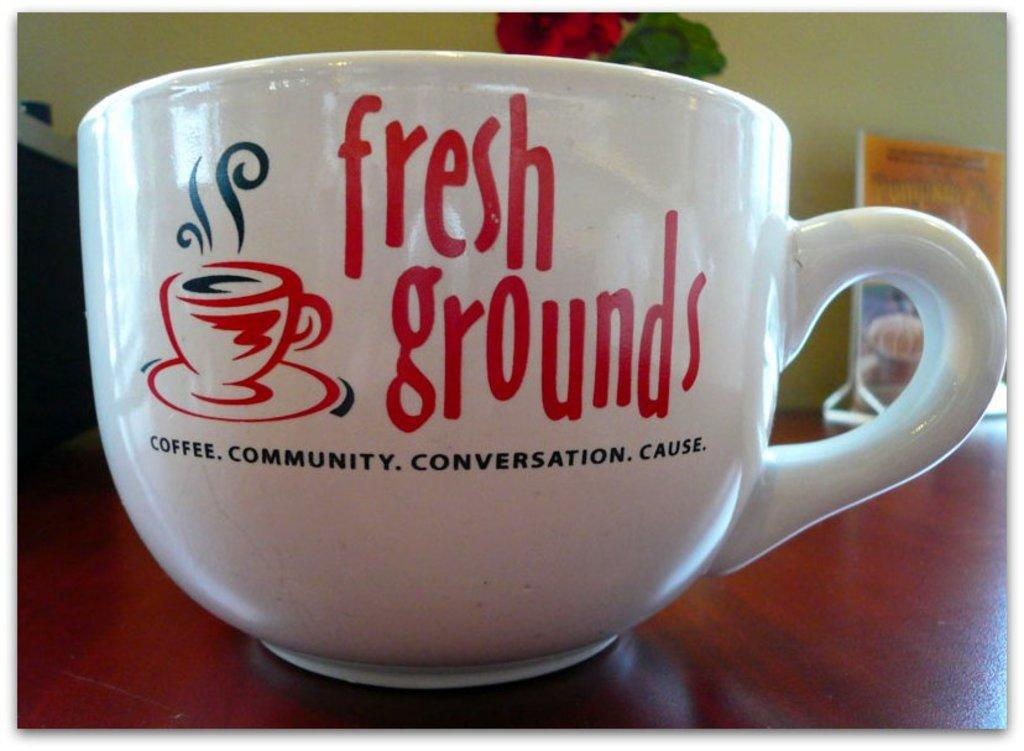<image>
Render a clear and concise summary of the photo. A coffee mug with fresh grounds displayed next to a picture of a cup of coffee. 